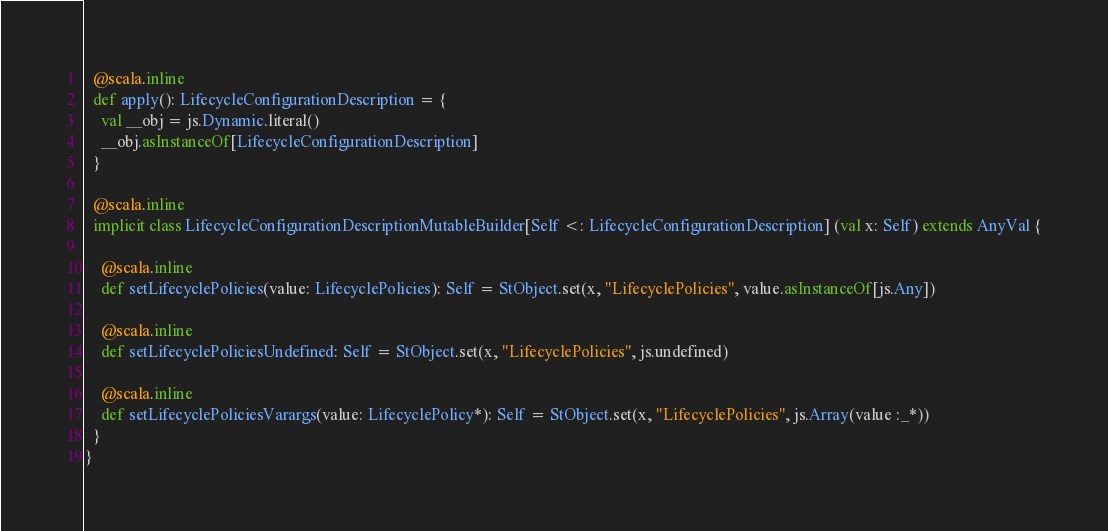Convert code to text. <code><loc_0><loc_0><loc_500><loc_500><_Scala_>  @scala.inline
  def apply(): LifecycleConfigurationDescription = {
    val __obj = js.Dynamic.literal()
    __obj.asInstanceOf[LifecycleConfigurationDescription]
  }
  
  @scala.inline
  implicit class LifecycleConfigurationDescriptionMutableBuilder[Self <: LifecycleConfigurationDescription] (val x: Self) extends AnyVal {
    
    @scala.inline
    def setLifecyclePolicies(value: LifecyclePolicies): Self = StObject.set(x, "LifecyclePolicies", value.asInstanceOf[js.Any])
    
    @scala.inline
    def setLifecyclePoliciesUndefined: Self = StObject.set(x, "LifecyclePolicies", js.undefined)
    
    @scala.inline
    def setLifecyclePoliciesVarargs(value: LifecyclePolicy*): Self = StObject.set(x, "LifecyclePolicies", js.Array(value :_*))
  }
}
</code> 